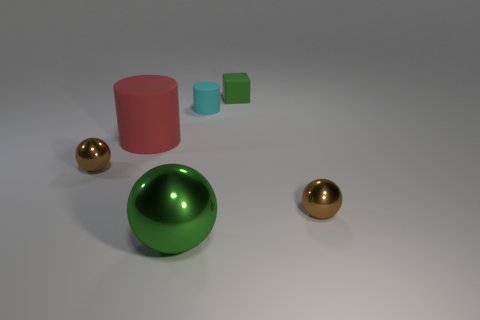What is the shape of the other object that is the same color as the large metal thing?
Offer a terse response. Cube. There is a red thing that is the same shape as the small cyan thing; what is it made of?
Your answer should be very brief. Rubber. Is the number of green rubber cubes that are in front of the block the same as the number of cyan rubber cylinders that are behind the tiny cyan matte object?
Your answer should be compact. Yes. What size is the matte cylinder left of the green thing that is in front of the small cyan cylinder?
Your answer should be compact. Large. The object that is right of the small cyan cylinder and in front of the tiny cube is made of what material?
Your response must be concise. Metal. How many other objects are the same size as the red object?
Offer a very short reply. 1. The tiny rubber cube has what color?
Provide a succinct answer. Green. There is a small thing to the left of the red matte object; is its color the same as the cylinder right of the large metallic ball?
Your answer should be compact. No. The cyan rubber cylinder has what size?
Your answer should be compact. Small. What size is the cylinder that is to the right of the large red rubber thing?
Your response must be concise. Small. 